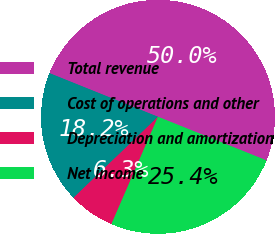<chart> <loc_0><loc_0><loc_500><loc_500><pie_chart><fcel>Total revenue<fcel>Cost of operations and other<fcel>Depreciation and amortization<fcel>Net income<nl><fcel>50.0%<fcel>18.25%<fcel>6.32%<fcel>25.43%<nl></chart> 